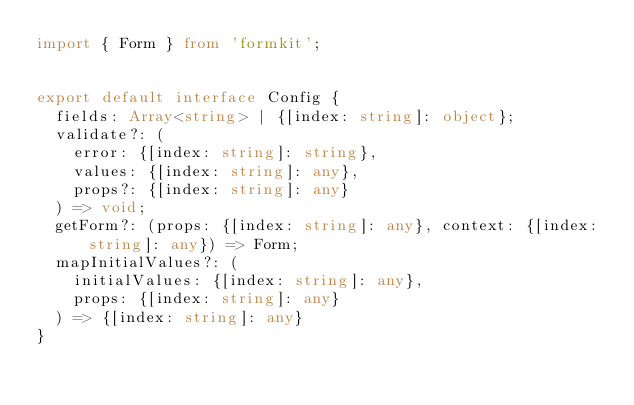<code> <loc_0><loc_0><loc_500><loc_500><_TypeScript_>import { Form } from 'formkit';


export default interface Config {
  fields: Array<string> | {[index: string]: object};
  validate?: (
    error: {[index: string]: string},
    values: {[index: string]: any},
    props?: {[index: string]: any}
  ) => void;
  getForm?: (props: {[index: string]: any}, context: {[index: string]: any}) => Form;
  mapInitialValues?: (
    initialValues: {[index: string]: any},
    props: {[index: string]: any}
  ) => {[index: string]: any}
}
</code> 